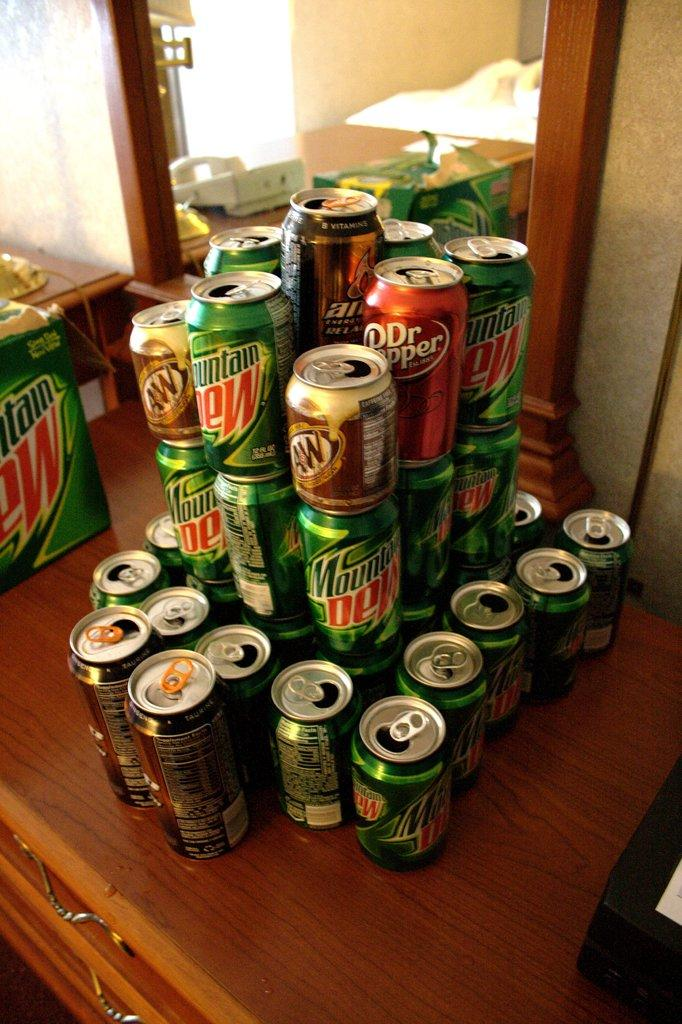<image>
Present a compact description of the photo's key features. some mountain dew and dr. pepper cans all together 